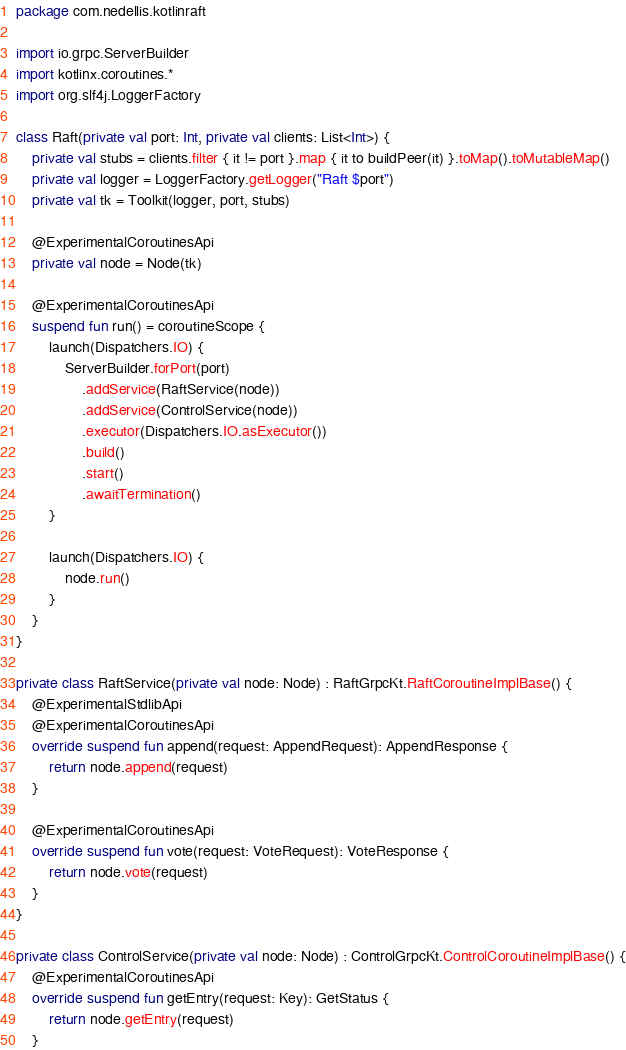Convert code to text. <code><loc_0><loc_0><loc_500><loc_500><_Kotlin_>package com.nedellis.kotlinraft

import io.grpc.ServerBuilder
import kotlinx.coroutines.*
import org.slf4j.LoggerFactory

class Raft(private val port: Int, private val clients: List<Int>) {
    private val stubs = clients.filter { it != port }.map { it to buildPeer(it) }.toMap().toMutableMap()
    private val logger = LoggerFactory.getLogger("Raft $port")
    private val tk = Toolkit(logger, port, stubs)

    @ExperimentalCoroutinesApi
    private val node = Node(tk)

    @ExperimentalCoroutinesApi
    suspend fun run() = coroutineScope {
        launch(Dispatchers.IO) {
            ServerBuilder.forPort(port)
                .addService(RaftService(node))
                .addService(ControlService(node))
                .executor(Dispatchers.IO.asExecutor())
                .build()
                .start()
                .awaitTermination()
        }

        launch(Dispatchers.IO) {
            node.run()
        }
    }
}

private class RaftService(private val node: Node) : RaftGrpcKt.RaftCoroutineImplBase() {
    @ExperimentalStdlibApi
    @ExperimentalCoroutinesApi
    override suspend fun append(request: AppendRequest): AppendResponse {
        return node.append(request)
    }

    @ExperimentalCoroutinesApi
    override suspend fun vote(request: VoteRequest): VoteResponse {
        return node.vote(request)
    }
}

private class ControlService(private val node: Node) : ControlGrpcKt.ControlCoroutineImplBase() {
    @ExperimentalCoroutinesApi
    override suspend fun getEntry(request: Key): GetStatus {
        return node.getEntry(request)
    }
</code> 